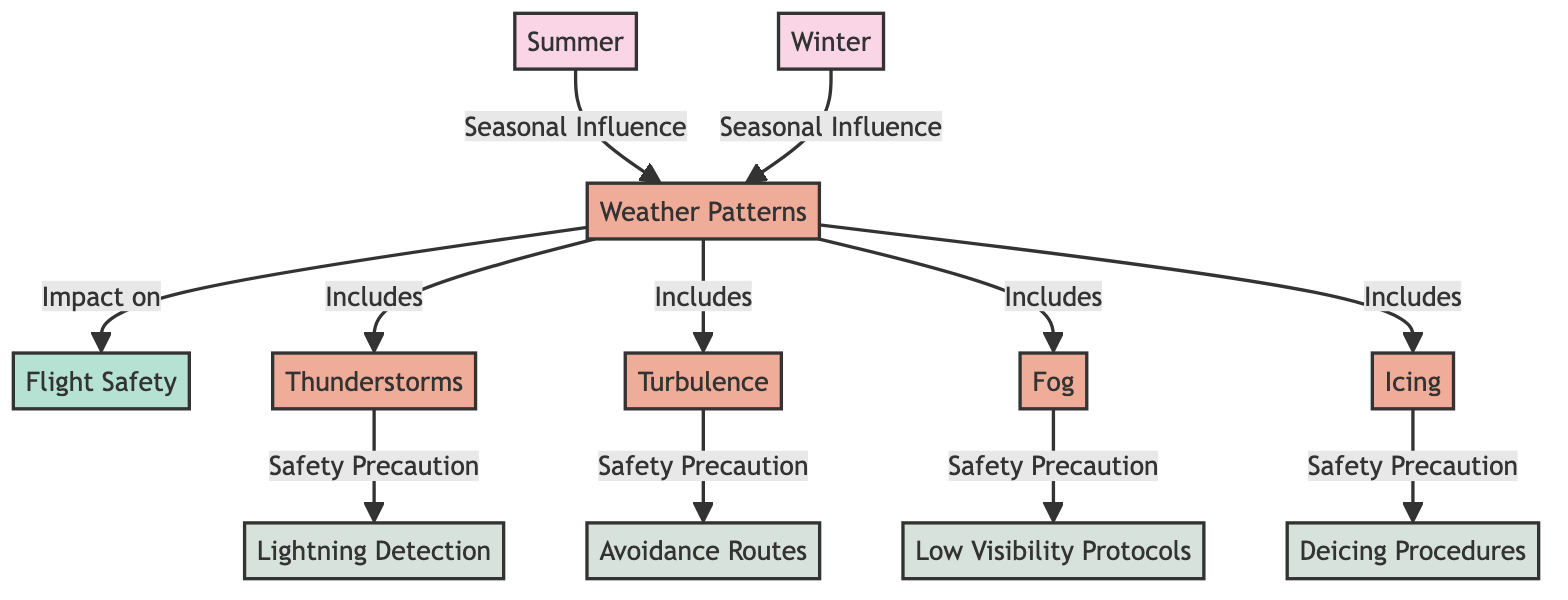What are the two major factors impacting flight safety in this diagram? The diagram highlights "Weather Patterns" and "Flight Safety" as the key factors, clearly connecting them.
Answer: Weather Patterns, Flight Safety How many weather conditions are included in the diagram? There are four weather conditions listed: Thunderstorms, Turbulence, Fog, and Icing, making it a total of four.
Answer: 4 Which safety precaution is associated with Thunderstorms? The diagram indicates "Lightning Detection" as the safety precaution related to Thunderstorms.
Answer: Lightning Detection What does Winter influence in the diagram? The Winter season impacts the Weather Patterns, indicating seasonal influence as stated within the diagram.
Answer: Weather Patterns Which safety precaution is linked with Fog? The diagram specifies that "Low Visibility Protocols" is the safety precaution that corresponds with Fog.
Answer: Low Visibility Protocols Identify the season that influences Icing. The diagram connects Icing to the seasonal influences, indicating that conditions related to Icing are primarily influenced by Winter.
Answer: Winter What precaution is taken for Turbulence? The diagram displays "Avoidance Routes" as the precaution taken to manage the risks associated with Turbulence.
Answer: Avoidance Routes Is there a specific precaution listed for each weather condition? Yes, each weather condition outlined in the diagram (Thunderstorms, Turbulence, Fog, Icing) has a corresponding safety precaution associated with it.
Answer: Yes Which safety precaution is required for Deicing? The diagram states that "Deicing Procedures" are necessary as the safety precaution when dealing with Icing conditions.
Answer: Deicing Procedures 